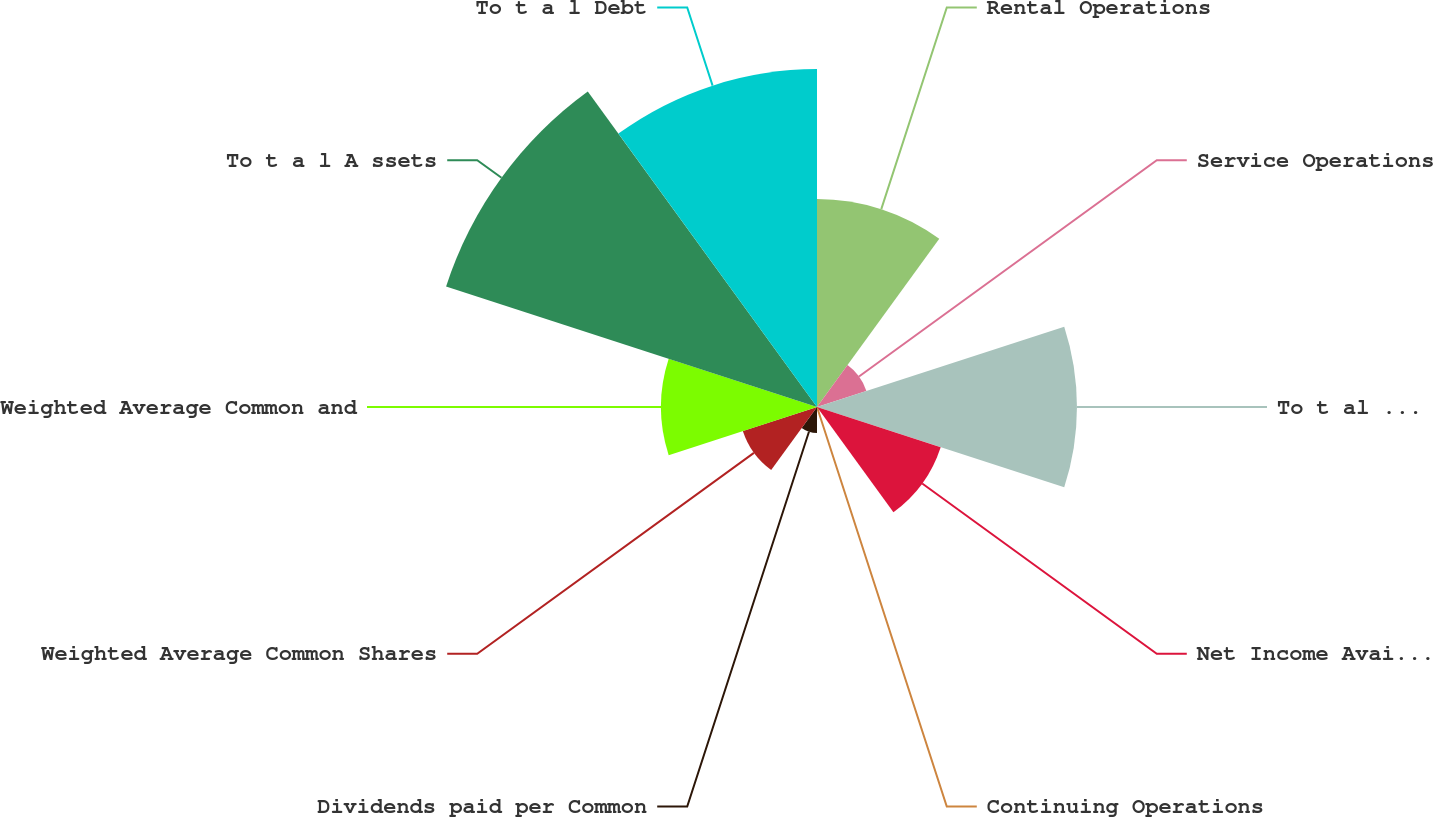<chart> <loc_0><loc_0><loc_500><loc_500><pie_chart><fcel>Rental Operations<fcel>Service Operations<fcel>To t al Revenues from<fcel>Net Income Available for<fcel>Continuing Operations<fcel>Dividends paid per Common<fcel>Weighted Average Common Shares<fcel>Weighted Average Common and<fcel>To t a l A ssets<fcel>To t a l Debt<nl><fcel>12.7%<fcel>3.17%<fcel>15.87%<fcel>7.94%<fcel>0.0%<fcel>1.59%<fcel>4.76%<fcel>9.52%<fcel>23.81%<fcel>20.63%<nl></chart> 